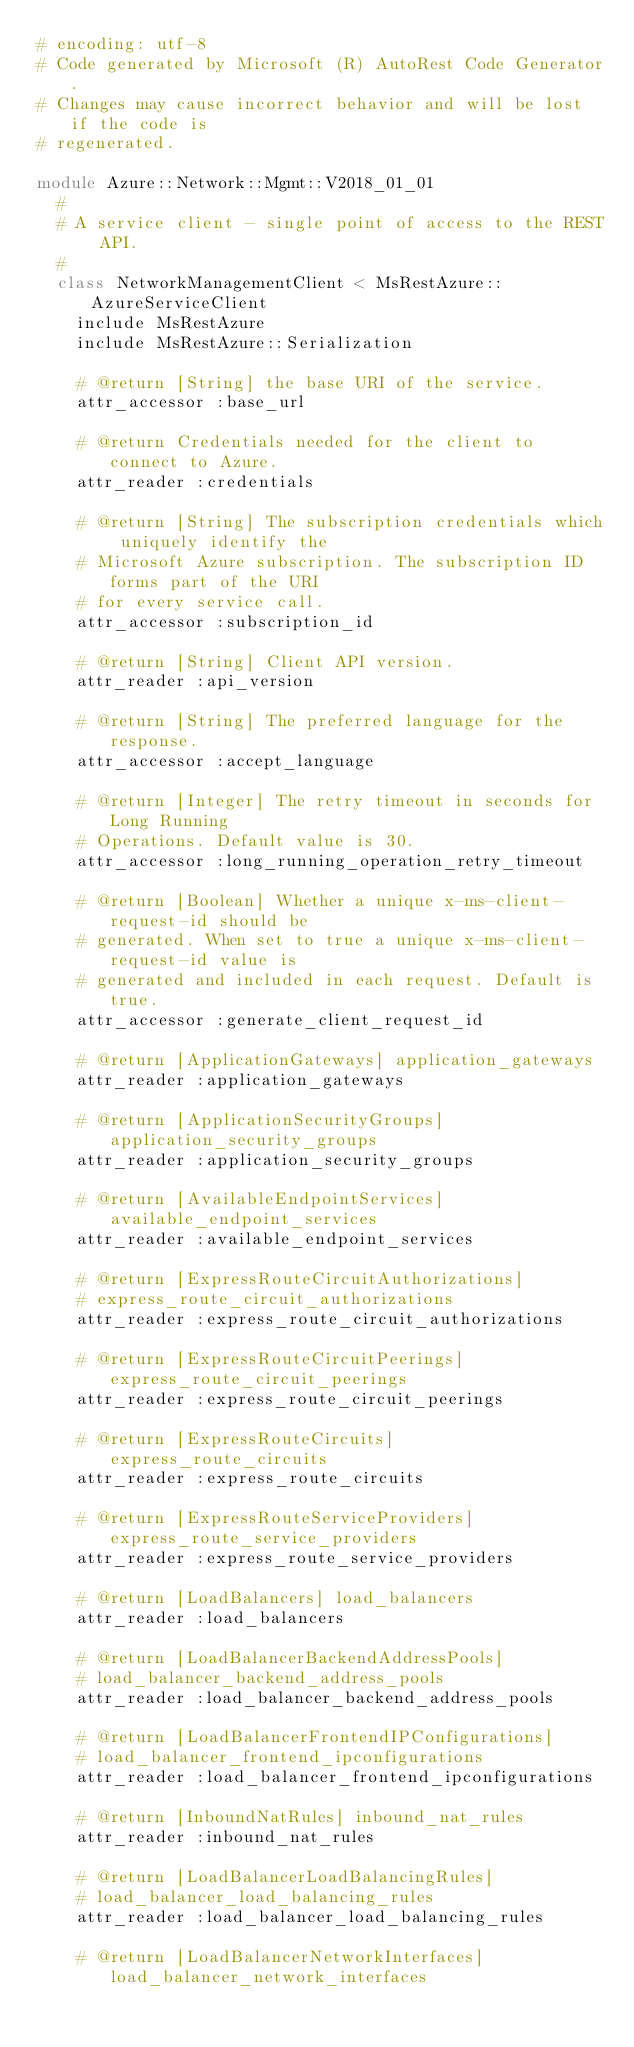Convert code to text. <code><loc_0><loc_0><loc_500><loc_500><_Ruby_># encoding: utf-8
# Code generated by Microsoft (R) AutoRest Code Generator.
# Changes may cause incorrect behavior and will be lost if the code is
# regenerated.

module Azure::Network::Mgmt::V2018_01_01
  #
  # A service client - single point of access to the REST API.
  #
  class NetworkManagementClient < MsRestAzure::AzureServiceClient
    include MsRestAzure
    include MsRestAzure::Serialization

    # @return [String] the base URI of the service.
    attr_accessor :base_url

    # @return Credentials needed for the client to connect to Azure.
    attr_reader :credentials

    # @return [String] The subscription credentials which uniquely identify the
    # Microsoft Azure subscription. The subscription ID forms part of the URI
    # for every service call.
    attr_accessor :subscription_id

    # @return [String] Client API version.
    attr_reader :api_version

    # @return [String] The preferred language for the response.
    attr_accessor :accept_language

    # @return [Integer] The retry timeout in seconds for Long Running
    # Operations. Default value is 30.
    attr_accessor :long_running_operation_retry_timeout

    # @return [Boolean] Whether a unique x-ms-client-request-id should be
    # generated. When set to true a unique x-ms-client-request-id value is
    # generated and included in each request. Default is true.
    attr_accessor :generate_client_request_id

    # @return [ApplicationGateways] application_gateways
    attr_reader :application_gateways

    # @return [ApplicationSecurityGroups] application_security_groups
    attr_reader :application_security_groups

    # @return [AvailableEndpointServices] available_endpoint_services
    attr_reader :available_endpoint_services

    # @return [ExpressRouteCircuitAuthorizations]
    # express_route_circuit_authorizations
    attr_reader :express_route_circuit_authorizations

    # @return [ExpressRouteCircuitPeerings] express_route_circuit_peerings
    attr_reader :express_route_circuit_peerings

    # @return [ExpressRouteCircuits] express_route_circuits
    attr_reader :express_route_circuits

    # @return [ExpressRouteServiceProviders] express_route_service_providers
    attr_reader :express_route_service_providers

    # @return [LoadBalancers] load_balancers
    attr_reader :load_balancers

    # @return [LoadBalancerBackendAddressPools]
    # load_balancer_backend_address_pools
    attr_reader :load_balancer_backend_address_pools

    # @return [LoadBalancerFrontendIPConfigurations]
    # load_balancer_frontend_ipconfigurations
    attr_reader :load_balancer_frontend_ipconfigurations

    # @return [InboundNatRules] inbound_nat_rules
    attr_reader :inbound_nat_rules

    # @return [LoadBalancerLoadBalancingRules]
    # load_balancer_load_balancing_rules
    attr_reader :load_balancer_load_balancing_rules

    # @return [LoadBalancerNetworkInterfaces] load_balancer_network_interfaces</code> 